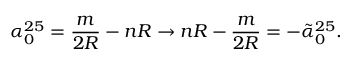Convert formula to latex. <formula><loc_0><loc_0><loc_500><loc_500>\alpha _ { 0 } ^ { 2 5 } = \frac { m } { 2 R } - n R \rightarrow n R - \frac { m } { 2 R } = - \tilde { \alpha } _ { 0 } ^ { 2 5 } .</formula> 